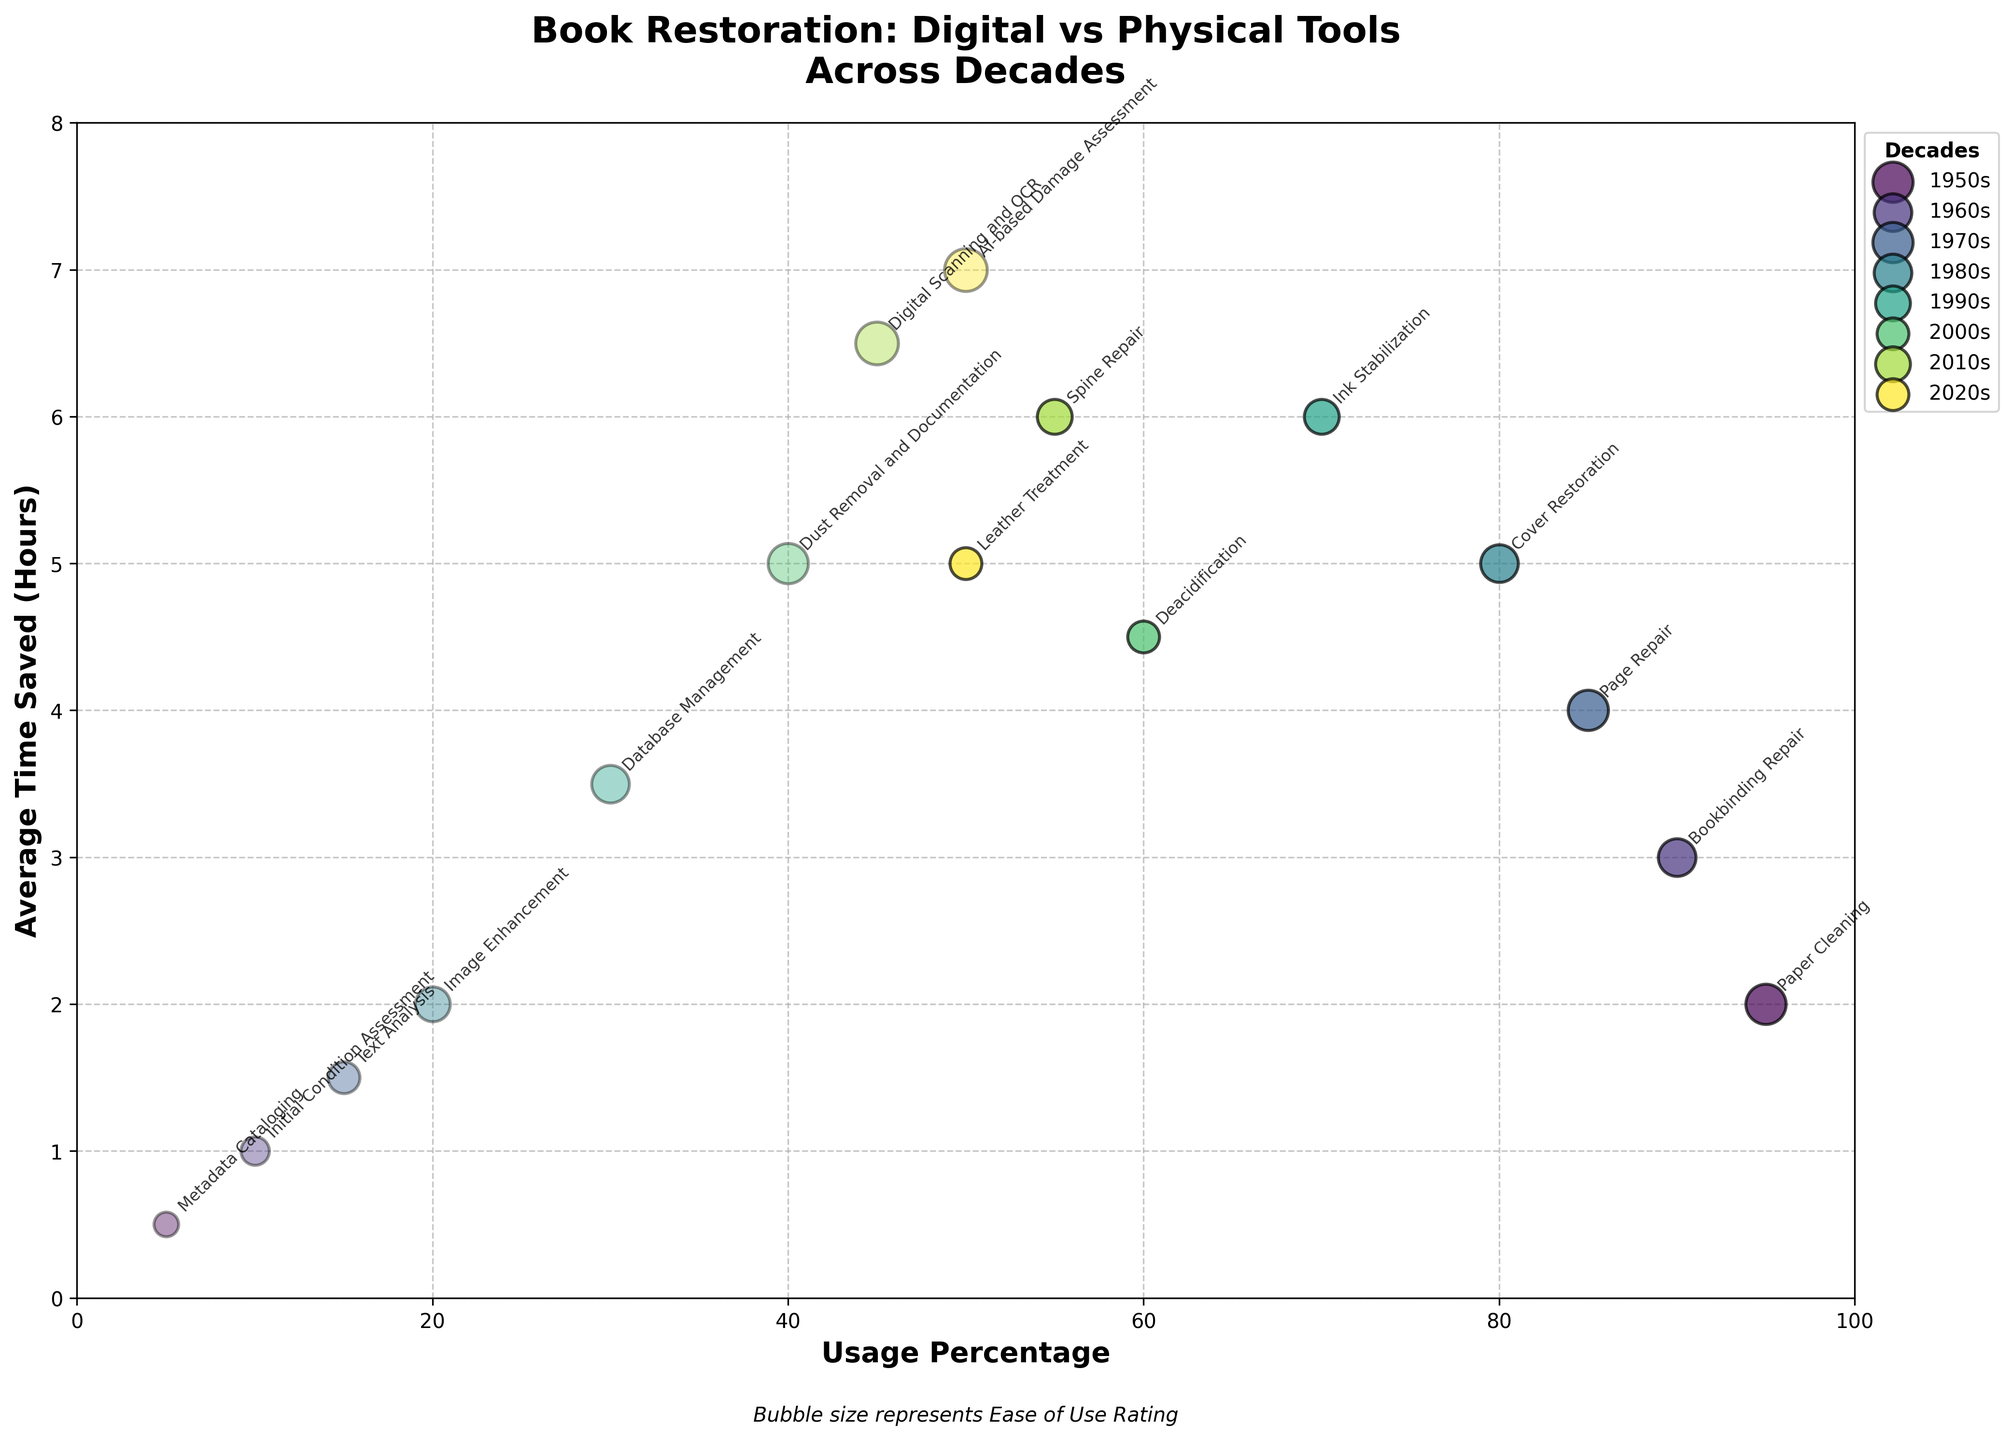what is the title of the plot? The title can be found at the top of the plot. It summarizes what the plot is about.
Answer: Book Restoration: Digital vs Physical Tools Across Decades What is the average ease of use rating for digital tools in the 2020s? There are two methods for each decade-row. For digital tools in the 2020s, we look for digital tools' ease-of-use rating, which is 9.
Answer: 9 Which has higher average time saved in the 1980s, physical or digital tools? For the 1980s, note the average time saved for the physical (5 hours) and digital (2 hours) tools. Compare these values.
Answer: Physical tools What is the bubble size representing for a digital tool with 30% usage in the 1990s? In the plot, the bubble size is related to the ease of use rating. For the digital tool with 30% usage (in the 1990s), the bubble size should correspond to an ease of use rating of 7.
Answer: 7 Between which decades does digital tool usage increase the most? Compare the increment of digital tool usage percentages across each decade. The largest increase is observed from the 2000s (40%) to the 2010s (45%).
Answer: 2000s to 2010s Do any decades have equal usage percentages for both digital and physical tools? Look for decades where the usage percentages for digital and physical tools are equal. The 2020s have 50% for both digital and physical tools.
Answer: 2020s Which decade has the highest ease of use rating for digital tools? Check each decade's ease of use rating for digital tools. The maximum rating is seen in the 2020s (9).
Answer: 2020s How many different colors represent the decades, and what do the colors signify? Every decade is represented with a unique color. There are 8 decades, hence 8 different colors. Each color signifies data pertaining to a particular decade.
Answer: 8, signifies decades Which decade has the highest average time saved for physical tools? Identify the average time saved by each decade for physical tools. The 1990s save the most with 6 hours.
Answer: 1990s What does the positioning on x-axis and y-axis respectively represent? The x-axis represents usage percentage while the y-axis represents average time saved in hours.
Answer: usage percentage and average time saved in hours 